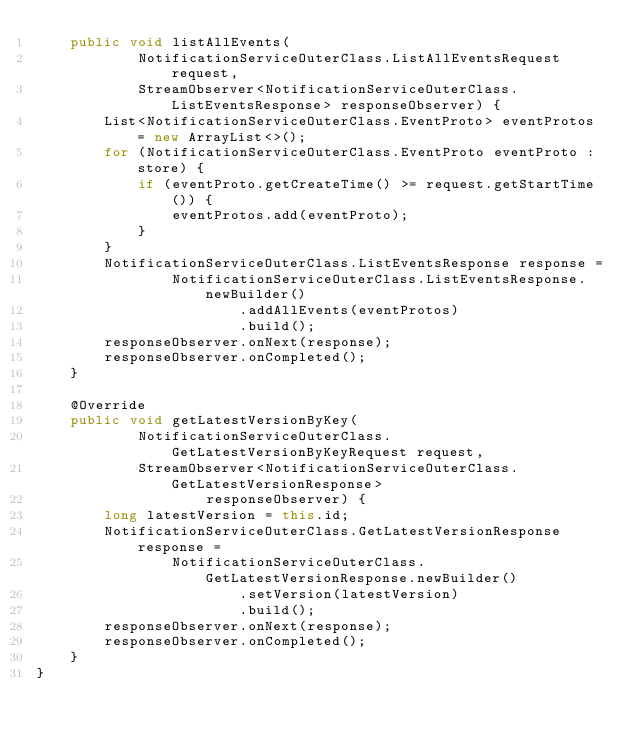<code> <loc_0><loc_0><loc_500><loc_500><_Java_>    public void listAllEvents(
            NotificationServiceOuterClass.ListAllEventsRequest request,
            StreamObserver<NotificationServiceOuterClass.ListEventsResponse> responseObserver) {
        List<NotificationServiceOuterClass.EventProto> eventProtos = new ArrayList<>();
        for (NotificationServiceOuterClass.EventProto eventProto : store) {
            if (eventProto.getCreateTime() >= request.getStartTime()) {
                eventProtos.add(eventProto);
            }
        }
        NotificationServiceOuterClass.ListEventsResponse response =
                NotificationServiceOuterClass.ListEventsResponse.newBuilder()
                        .addAllEvents(eventProtos)
                        .build();
        responseObserver.onNext(response);
        responseObserver.onCompleted();
    }

    @Override
    public void getLatestVersionByKey(
            NotificationServiceOuterClass.GetLatestVersionByKeyRequest request,
            StreamObserver<NotificationServiceOuterClass.GetLatestVersionResponse>
                    responseObserver) {
        long latestVersion = this.id;
        NotificationServiceOuterClass.GetLatestVersionResponse response =
                NotificationServiceOuterClass.GetLatestVersionResponse.newBuilder()
                        .setVersion(latestVersion)
                        .build();
        responseObserver.onNext(response);
        responseObserver.onCompleted();
    }
}
</code> 